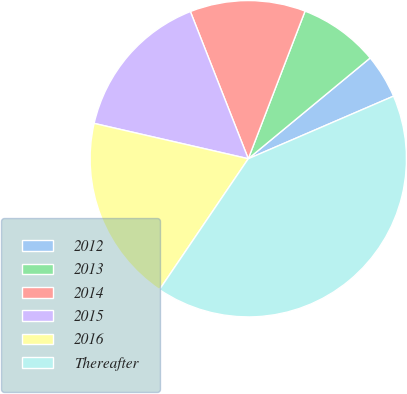Convert chart to OTSL. <chart><loc_0><loc_0><loc_500><loc_500><pie_chart><fcel>2012<fcel>2013<fcel>2014<fcel>2015<fcel>2016<fcel>Thereafter<nl><fcel>4.52%<fcel>8.16%<fcel>11.81%<fcel>15.45%<fcel>19.1%<fcel>40.97%<nl></chart> 